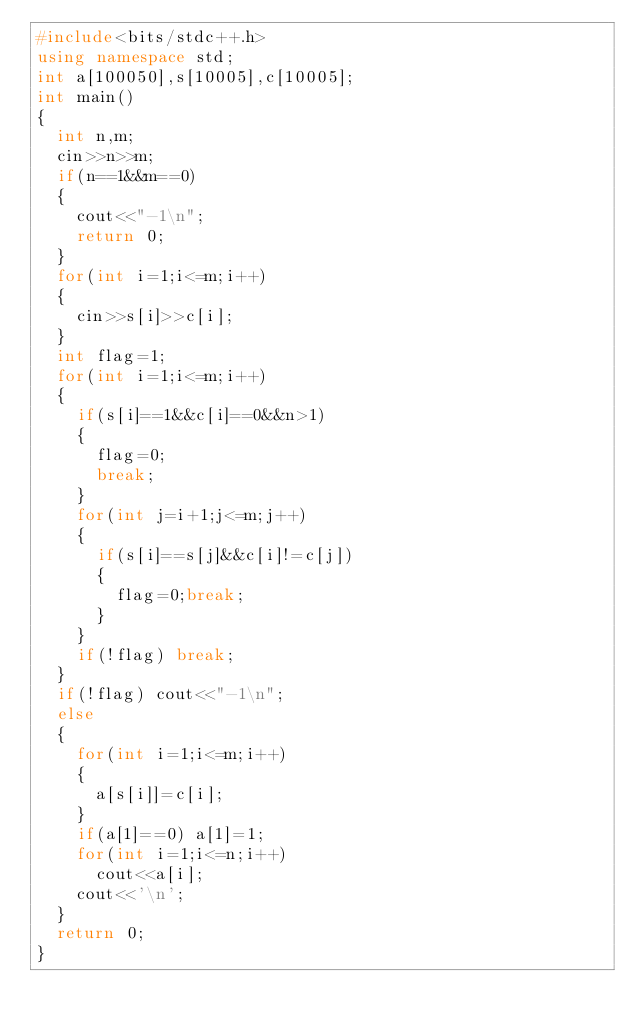<code> <loc_0><loc_0><loc_500><loc_500><_C++_>#include<bits/stdc++.h>
using namespace std;
int a[100050],s[10005],c[10005];
int main()
{
	int n,m;
	cin>>n>>m;
	if(n==1&&m==0)
	{
		cout<<"-1\n";
		return 0;
	}
	for(int i=1;i<=m;i++)
	{
		cin>>s[i]>>c[i];
	}
	int flag=1;
	for(int i=1;i<=m;i++)
	{
		if(s[i]==1&&c[i]==0&&n>1) 
		{
			flag=0;
			break;
		} 
		for(int j=i+1;j<=m;j++)
		{
			if(s[i]==s[j]&&c[i]!=c[j])
			{
				flag=0;break;
			}
		}
		if(!flag) break;
	}
	if(!flag) cout<<"-1\n";
	else
	{
		for(int i=1;i<=m;i++)
		{
			a[s[i]]=c[i];
		}
		if(a[1]==0) a[1]=1;
		for(int i=1;i<=n;i++)
			cout<<a[i];
		cout<<'\n';
	}
	return 0;
} </code> 